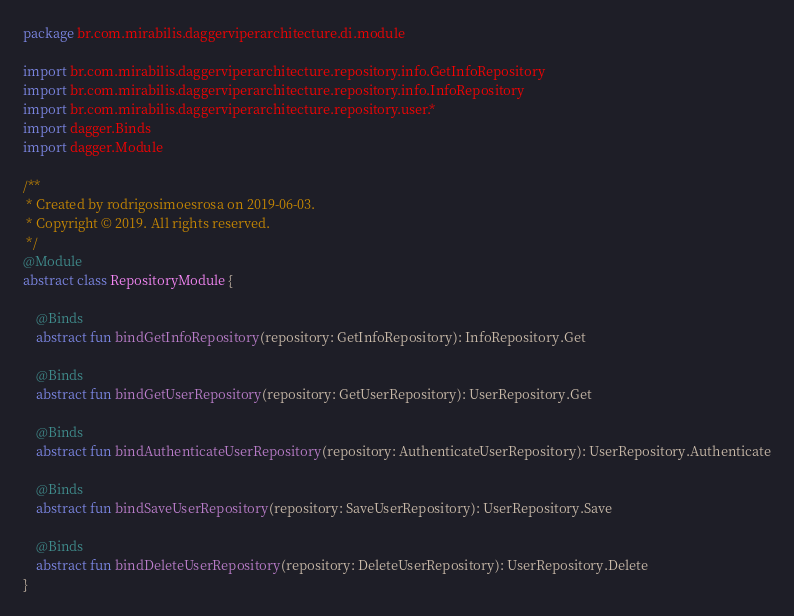<code> <loc_0><loc_0><loc_500><loc_500><_Kotlin_>package br.com.mirabilis.daggerviperarchitecture.di.module

import br.com.mirabilis.daggerviperarchitecture.repository.info.GetInfoRepository
import br.com.mirabilis.daggerviperarchitecture.repository.info.InfoRepository
import br.com.mirabilis.daggerviperarchitecture.repository.user.*
import dagger.Binds
import dagger.Module

/**
 * Created by rodrigosimoesrosa on 2019-06-03.
 * Copyright © 2019. All rights reserved.
 */
@Module
abstract class RepositoryModule {

    @Binds
    abstract fun bindGetInfoRepository(repository: GetInfoRepository): InfoRepository.Get

    @Binds
    abstract fun bindGetUserRepository(repository: GetUserRepository): UserRepository.Get

    @Binds
    abstract fun bindAuthenticateUserRepository(repository: AuthenticateUserRepository): UserRepository.Authenticate

    @Binds
    abstract fun bindSaveUserRepository(repository: SaveUserRepository): UserRepository.Save

    @Binds
    abstract fun bindDeleteUserRepository(repository: DeleteUserRepository): UserRepository.Delete
}</code> 